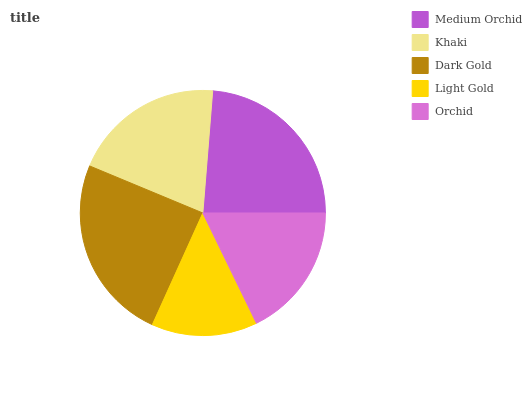Is Light Gold the minimum?
Answer yes or no. Yes. Is Dark Gold the maximum?
Answer yes or no. Yes. Is Khaki the minimum?
Answer yes or no. No. Is Khaki the maximum?
Answer yes or no. No. Is Medium Orchid greater than Khaki?
Answer yes or no. Yes. Is Khaki less than Medium Orchid?
Answer yes or no. Yes. Is Khaki greater than Medium Orchid?
Answer yes or no. No. Is Medium Orchid less than Khaki?
Answer yes or no. No. Is Khaki the high median?
Answer yes or no. Yes. Is Khaki the low median?
Answer yes or no. Yes. Is Medium Orchid the high median?
Answer yes or no. No. Is Medium Orchid the low median?
Answer yes or no. No. 